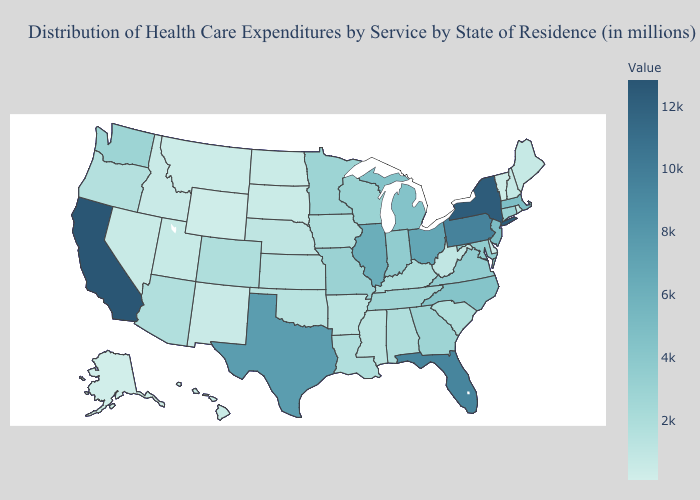Does West Virginia have the lowest value in the South?
Concise answer only. No. Does the map have missing data?
Keep it brief. No. Does Kansas have a higher value than Alaska?
Quick response, please. Yes. Does Utah have the lowest value in the USA?
Write a very short answer. No. Among the states that border Oregon , which have the lowest value?
Quick response, please. Idaho. Does Delaware have the lowest value in the South?
Be succinct. Yes. 